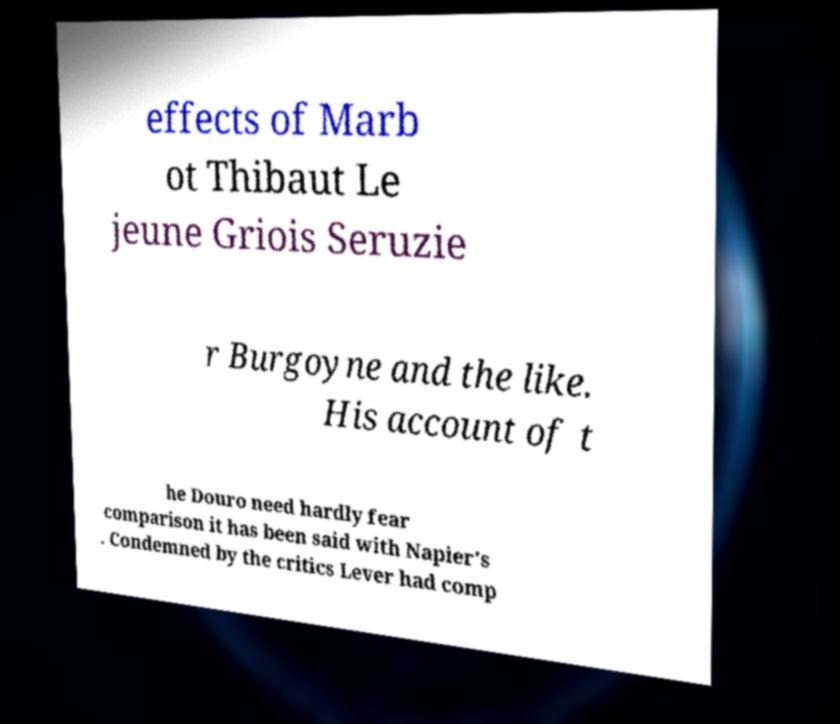I need the written content from this picture converted into text. Can you do that? effects of Marb ot Thibaut Le jeune Griois Seruzie r Burgoyne and the like. His account of t he Douro need hardly fear comparison it has been said with Napier's . Condemned by the critics Lever had comp 